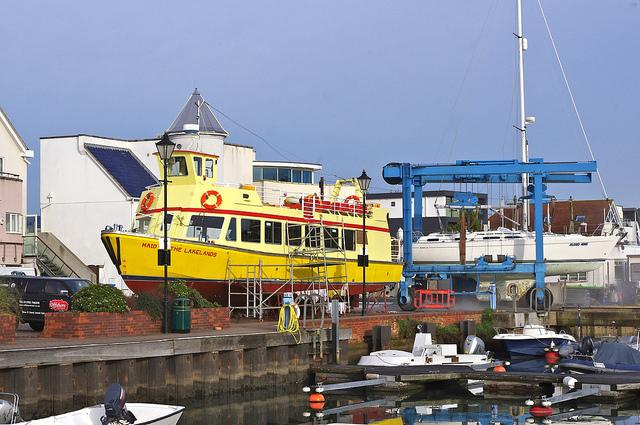What are the red planters on the left made from?

Choices:
A) metal
B) aluminum
C) bricks
D) plastic bricks 